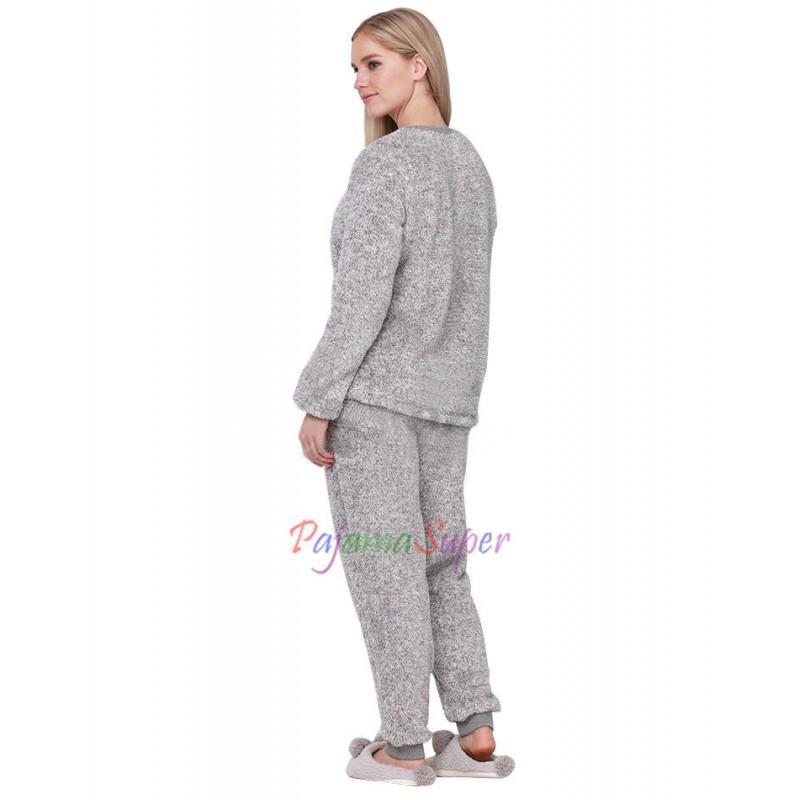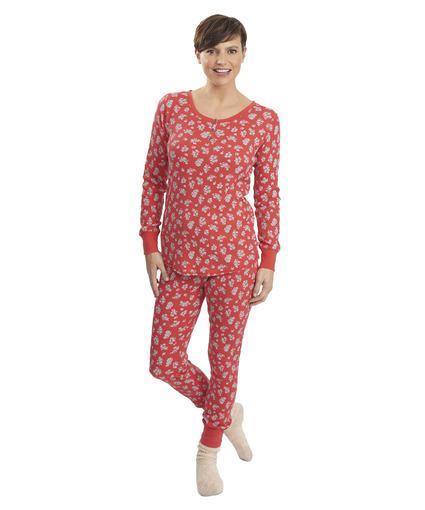The first image is the image on the left, the second image is the image on the right. Considering the images on both sides, is "The girl on the left is wearing primarily gray pajamas." valid? Answer yes or no. Yes. The first image is the image on the left, the second image is the image on the right. Analyze the images presented: Is the assertion "Some of the pajamas are one piece and all of them have skin tight legs." valid? Answer yes or no. No. 